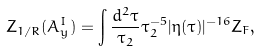<formula> <loc_0><loc_0><loc_500><loc_500>Z _ { 1 / R } ( A _ { y } ^ { I } ) = \int \frac { d ^ { 2 } \tau } { \tau _ { 2 } } \tau _ { 2 } ^ { - 5 } | \eta ( \tau ) | ^ { - 1 6 } Z _ { F } ,</formula> 